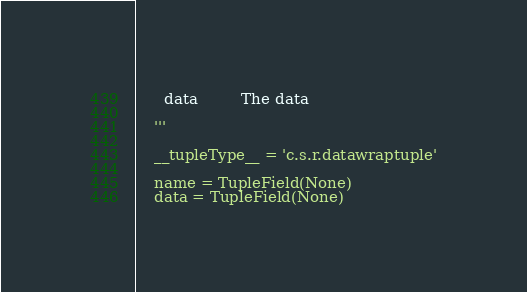Convert code to text. <code><loc_0><loc_0><loc_500><loc_500><_Python_>      data         The data

    '''

    __tupleType__ = 'c.s.r.datawraptuple'

    name = TupleField(None)
    data = TupleField(None)
</code> 